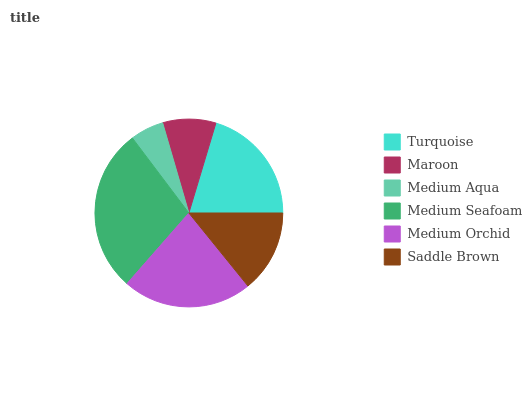Is Medium Aqua the minimum?
Answer yes or no. Yes. Is Medium Seafoam the maximum?
Answer yes or no. Yes. Is Maroon the minimum?
Answer yes or no. No. Is Maroon the maximum?
Answer yes or no. No. Is Turquoise greater than Maroon?
Answer yes or no. Yes. Is Maroon less than Turquoise?
Answer yes or no. Yes. Is Maroon greater than Turquoise?
Answer yes or no. No. Is Turquoise less than Maroon?
Answer yes or no. No. Is Turquoise the high median?
Answer yes or no. Yes. Is Saddle Brown the low median?
Answer yes or no. Yes. Is Medium Aqua the high median?
Answer yes or no. No. Is Medium Orchid the low median?
Answer yes or no. No. 